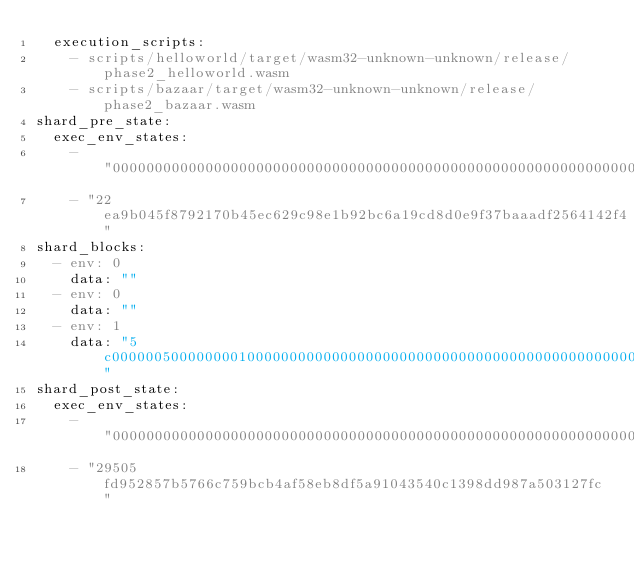<code> <loc_0><loc_0><loc_500><loc_500><_YAML_>  execution_scripts:
    - scripts/helloworld/target/wasm32-unknown-unknown/release/phase2_helloworld.wasm
    - scripts/bazaar/target/wasm32-unknown-unknown/release/phase2_bazaar.wasm
shard_pre_state:
  exec_env_states:
    - "0000000000000000000000000000000000000000000000000000000000000000"
    - "22ea9b045f8792170b45ec629c98e1b92bc6a19cd8d0e9f37baaadf2564142f4"
shard_blocks:
  - env: 0
    data: ""
  - env: 0
    data: ""
  - env: 1
    data: "5c0000005000000001000000000000000000000000000000000000000000000000000000000000000000000000000000020000000000000001010101010101010101010101010101010101010101010101010101010101010400000000000000"
shard_post_state:
  exec_env_states:
    - "0000000000000000000000000000000000000000000000000000000000000000"
    - "29505fd952857b5766c759bcb4af58eb8df5a91043540c1398dd987a503127fc"
</code> 